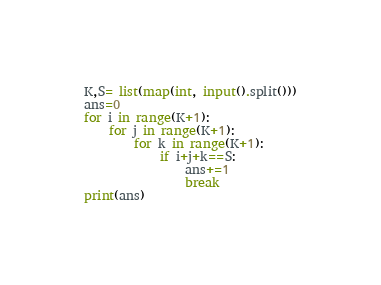Convert code to text. <code><loc_0><loc_0><loc_500><loc_500><_Python_>K,S= list(map(int, input().split()))
ans=0
for i in range(K+1):
    for j in range(K+1):
        for k in range(K+1):
            if i+j+k==S:
                ans+=1
                break
print(ans)</code> 